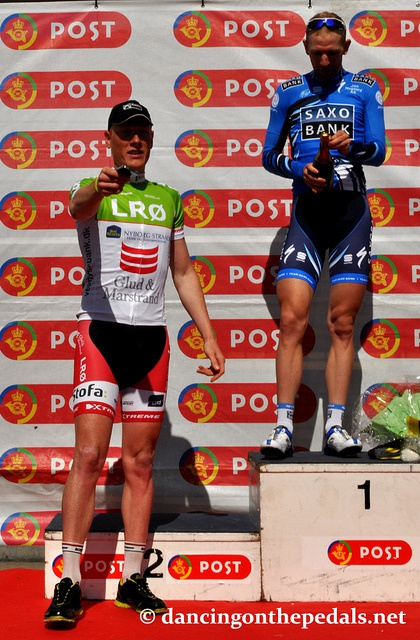Describe the objects in this image and their specific colors. I can see people in black, brown, and darkgray tones, people in black, maroon, navy, and brown tones, bottle in black, maroon, blue, and brown tones, and cell phone in black, gray, maroon, and darkgray tones in this image. 